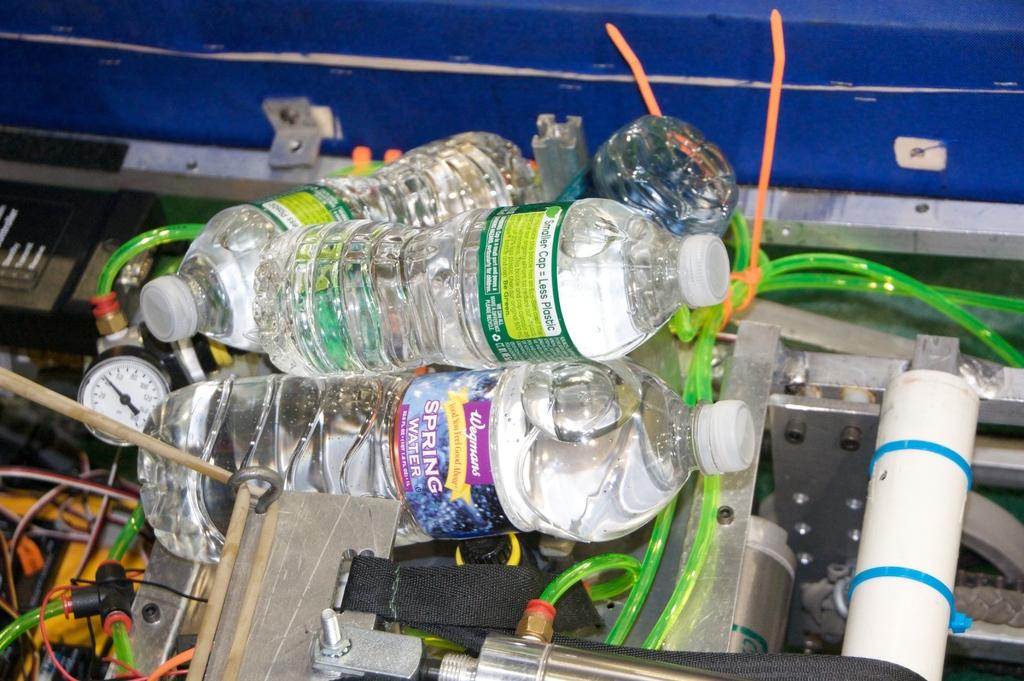What type of objects can be seen in the image? There are bottles, metal objects, wires, and devices in the image. How are these objects arranged or placed in the image? These objects are placed in a box. What is the flavor of the quiet in the image? There is no quiet or flavor present in the image; it features objects placed in a box. Can you describe the tongue of the device in the image? There is no tongue associated with the devices in the image; they are electronic or mechanical objects. 